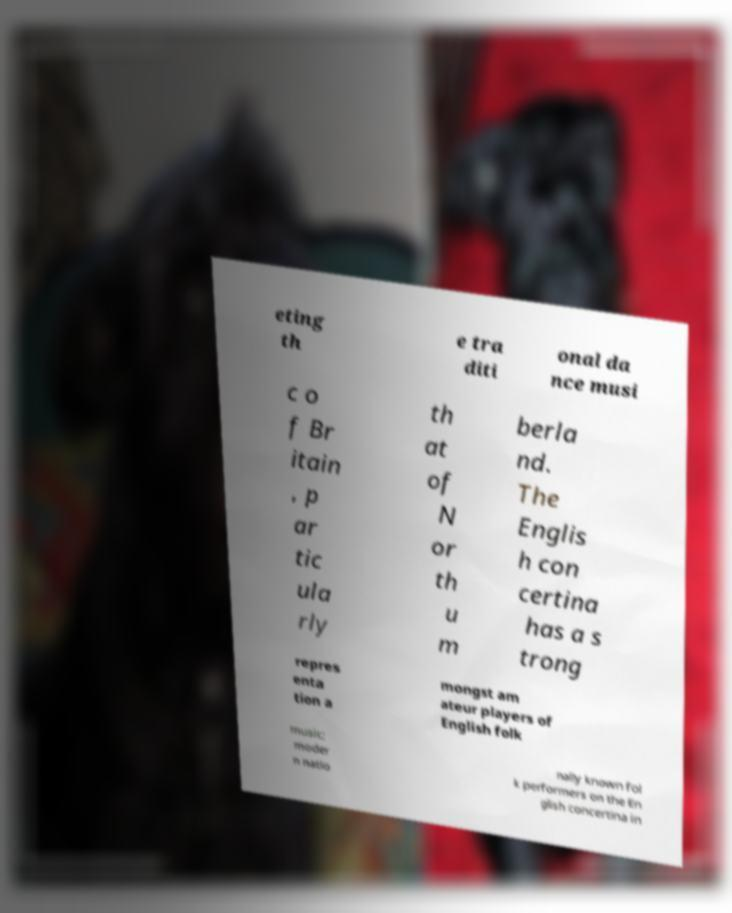For documentation purposes, I need the text within this image transcribed. Could you provide that? eting th e tra diti onal da nce musi c o f Br itain , p ar tic ula rly th at of N or th u m berla nd. The Englis h con certina has a s trong repres enta tion a mongst am ateur players of English folk music; moder n natio nally known fol k performers on the En glish concertina in 